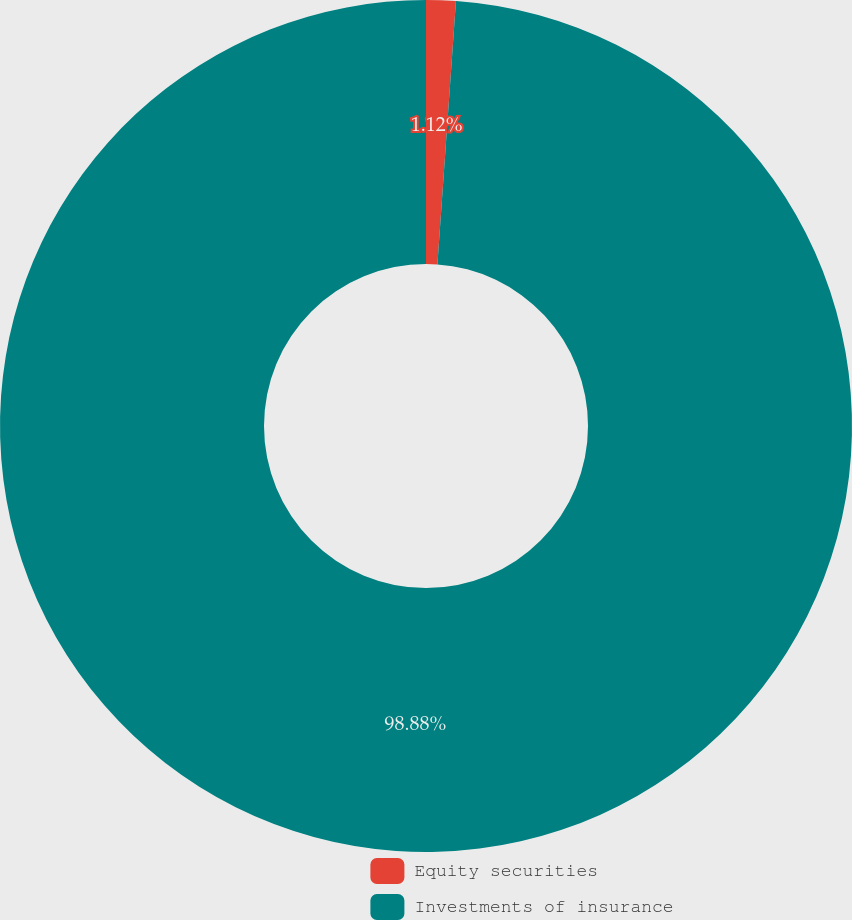Convert chart to OTSL. <chart><loc_0><loc_0><loc_500><loc_500><pie_chart><fcel>Equity securities<fcel>Investments of insurance<nl><fcel>1.12%<fcel>98.88%<nl></chart> 